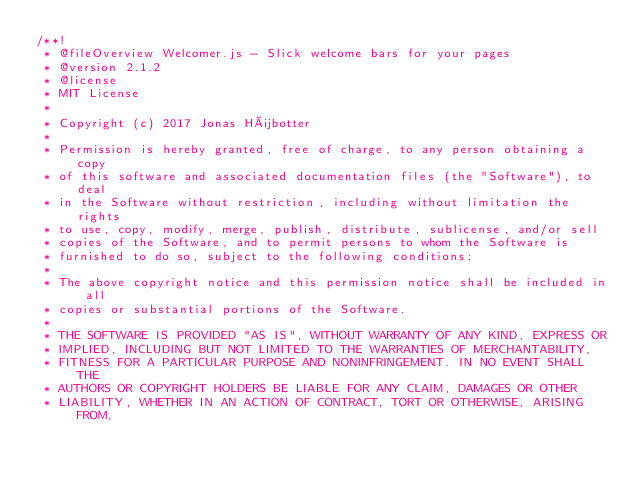Convert code to text. <code><loc_0><loc_0><loc_500><loc_500><_JavaScript_>/**!
 * @fileOverview Welcomer.js - Slick welcome bars for your pages
 * @version 2.1.2
 * @license
 * MIT License
 *
 * Copyright (c) 2017 Jonas Hübotter
 *
 * Permission is hereby granted, free of charge, to any person obtaining a copy
 * of this software and associated documentation files (the "Software"), to deal
 * in the Software without restriction, including without limitation the rights
 * to use, copy, modify, merge, publish, distribute, sublicense, and/or sell
 * copies of the Software, and to permit persons to whom the Software is
 * furnished to do so, subject to the following conditions:
 *
 * The above copyright notice and this permission notice shall be included in all
 * copies or substantial portions of the Software.
 *
 * THE SOFTWARE IS PROVIDED "AS IS", WITHOUT WARRANTY OF ANY KIND, EXPRESS OR
 * IMPLIED, INCLUDING BUT NOT LIMITED TO THE WARRANTIES OF MERCHANTABILITY,
 * FITNESS FOR A PARTICULAR PURPOSE AND NONINFRINGEMENT. IN NO EVENT SHALL THE
 * AUTHORS OR COPYRIGHT HOLDERS BE LIABLE FOR ANY CLAIM, DAMAGES OR OTHER
 * LIABILITY, WHETHER IN AN ACTION OF CONTRACT, TORT OR OTHERWISE, ARISING FROM,</code> 